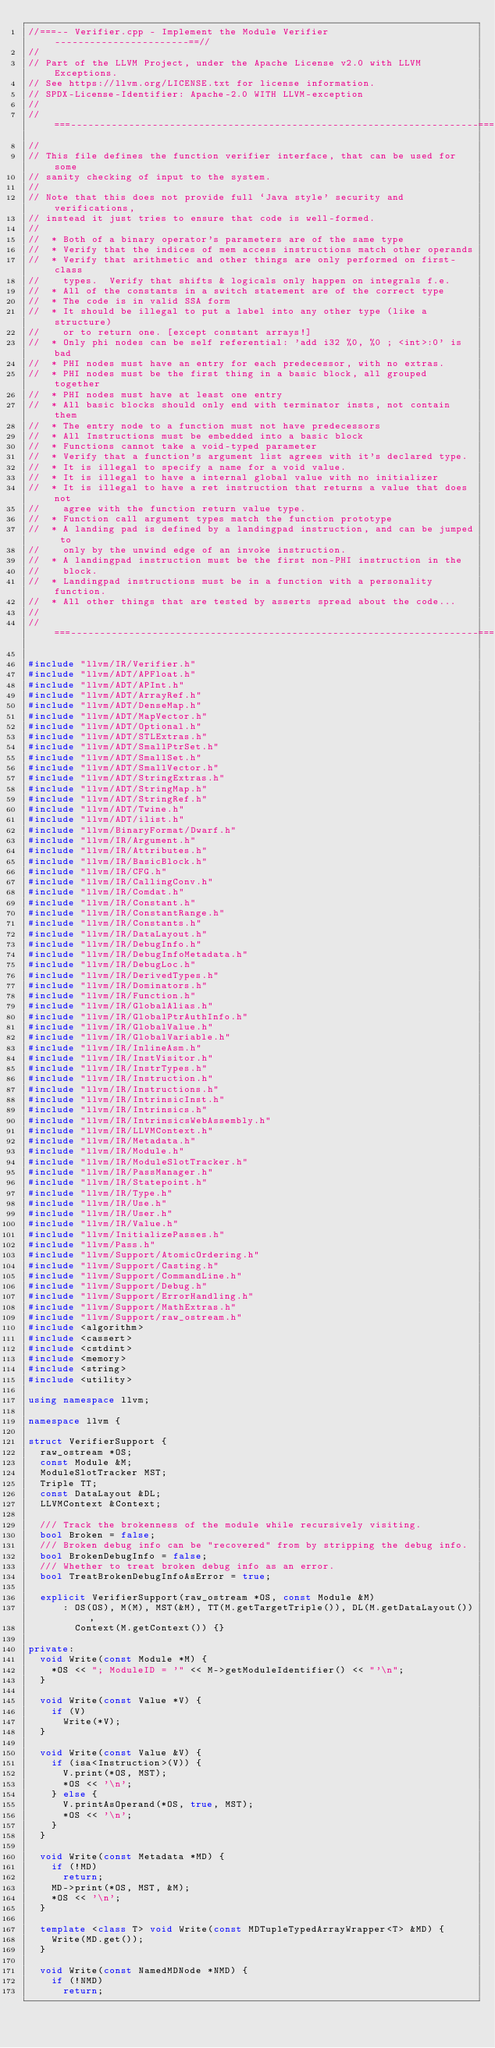Convert code to text. <code><loc_0><loc_0><loc_500><loc_500><_C++_>//===-- Verifier.cpp - Implement the Module Verifier -----------------------==//
//
// Part of the LLVM Project, under the Apache License v2.0 with LLVM Exceptions.
// See https://llvm.org/LICENSE.txt for license information.
// SPDX-License-Identifier: Apache-2.0 WITH LLVM-exception
//
//===----------------------------------------------------------------------===//
//
// This file defines the function verifier interface, that can be used for some
// sanity checking of input to the system.
//
// Note that this does not provide full `Java style' security and verifications,
// instead it just tries to ensure that code is well-formed.
//
//  * Both of a binary operator's parameters are of the same type
//  * Verify that the indices of mem access instructions match other operands
//  * Verify that arithmetic and other things are only performed on first-class
//    types.  Verify that shifts & logicals only happen on integrals f.e.
//  * All of the constants in a switch statement are of the correct type
//  * The code is in valid SSA form
//  * It should be illegal to put a label into any other type (like a structure)
//    or to return one. [except constant arrays!]
//  * Only phi nodes can be self referential: 'add i32 %0, %0 ; <int>:0' is bad
//  * PHI nodes must have an entry for each predecessor, with no extras.
//  * PHI nodes must be the first thing in a basic block, all grouped together
//  * PHI nodes must have at least one entry
//  * All basic blocks should only end with terminator insts, not contain them
//  * The entry node to a function must not have predecessors
//  * All Instructions must be embedded into a basic block
//  * Functions cannot take a void-typed parameter
//  * Verify that a function's argument list agrees with it's declared type.
//  * It is illegal to specify a name for a void value.
//  * It is illegal to have a internal global value with no initializer
//  * It is illegal to have a ret instruction that returns a value that does not
//    agree with the function return value type.
//  * Function call argument types match the function prototype
//  * A landing pad is defined by a landingpad instruction, and can be jumped to
//    only by the unwind edge of an invoke instruction.
//  * A landingpad instruction must be the first non-PHI instruction in the
//    block.
//  * Landingpad instructions must be in a function with a personality function.
//  * All other things that are tested by asserts spread about the code...
//
//===----------------------------------------------------------------------===//

#include "llvm/IR/Verifier.h"
#include "llvm/ADT/APFloat.h"
#include "llvm/ADT/APInt.h"
#include "llvm/ADT/ArrayRef.h"
#include "llvm/ADT/DenseMap.h"
#include "llvm/ADT/MapVector.h"
#include "llvm/ADT/Optional.h"
#include "llvm/ADT/STLExtras.h"
#include "llvm/ADT/SmallPtrSet.h"
#include "llvm/ADT/SmallSet.h"
#include "llvm/ADT/SmallVector.h"
#include "llvm/ADT/StringExtras.h"
#include "llvm/ADT/StringMap.h"
#include "llvm/ADT/StringRef.h"
#include "llvm/ADT/Twine.h"
#include "llvm/ADT/ilist.h"
#include "llvm/BinaryFormat/Dwarf.h"
#include "llvm/IR/Argument.h"
#include "llvm/IR/Attributes.h"
#include "llvm/IR/BasicBlock.h"
#include "llvm/IR/CFG.h"
#include "llvm/IR/CallingConv.h"
#include "llvm/IR/Comdat.h"
#include "llvm/IR/Constant.h"
#include "llvm/IR/ConstantRange.h"
#include "llvm/IR/Constants.h"
#include "llvm/IR/DataLayout.h"
#include "llvm/IR/DebugInfo.h"
#include "llvm/IR/DebugInfoMetadata.h"
#include "llvm/IR/DebugLoc.h"
#include "llvm/IR/DerivedTypes.h"
#include "llvm/IR/Dominators.h"
#include "llvm/IR/Function.h"
#include "llvm/IR/GlobalAlias.h"
#include "llvm/IR/GlobalPtrAuthInfo.h"
#include "llvm/IR/GlobalValue.h"
#include "llvm/IR/GlobalVariable.h"
#include "llvm/IR/InlineAsm.h"
#include "llvm/IR/InstVisitor.h"
#include "llvm/IR/InstrTypes.h"
#include "llvm/IR/Instruction.h"
#include "llvm/IR/Instructions.h"
#include "llvm/IR/IntrinsicInst.h"
#include "llvm/IR/Intrinsics.h"
#include "llvm/IR/IntrinsicsWebAssembly.h"
#include "llvm/IR/LLVMContext.h"
#include "llvm/IR/Metadata.h"
#include "llvm/IR/Module.h"
#include "llvm/IR/ModuleSlotTracker.h"
#include "llvm/IR/PassManager.h"
#include "llvm/IR/Statepoint.h"
#include "llvm/IR/Type.h"
#include "llvm/IR/Use.h"
#include "llvm/IR/User.h"
#include "llvm/IR/Value.h"
#include "llvm/InitializePasses.h"
#include "llvm/Pass.h"
#include "llvm/Support/AtomicOrdering.h"
#include "llvm/Support/Casting.h"
#include "llvm/Support/CommandLine.h"
#include "llvm/Support/Debug.h"
#include "llvm/Support/ErrorHandling.h"
#include "llvm/Support/MathExtras.h"
#include "llvm/Support/raw_ostream.h"
#include <algorithm>
#include <cassert>
#include <cstdint>
#include <memory>
#include <string>
#include <utility>

using namespace llvm;

namespace llvm {

struct VerifierSupport {
  raw_ostream *OS;
  const Module &M;
  ModuleSlotTracker MST;
  Triple TT;
  const DataLayout &DL;
  LLVMContext &Context;

  /// Track the brokenness of the module while recursively visiting.
  bool Broken = false;
  /// Broken debug info can be "recovered" from by stripping the debug info.
  bool BrokenDebugInfo = false;
  /// Whether to treat broken debug info as an error.
  bool TreatBrokenDebugInfoAsError = true;

  explicit VerifierSupport(raw_ostream *OS, const Module &M)
      : OS(OS), M(M), MST(&M), TT(M.getTargetTriple()), DL(M.getDataLayout()),
        Context(M.getContext()) {}

private:
  void Write(const Module *M) {
    *OS << "; ModuleID = '" << M->getModuleIdentifier() << "'\n";
  }

  void Write(const Value *V) {
    if (V)
      Write(*V);
  }

  void Write(const Value &V) {
    if (isa<Instruction>(V)) {
      V.print(*OS, MST);
      *OS << '\n';
    } else {
      V.printAsOperand(*OS, true, MST);
      *OS << '\n';
    }
  }

  void Write(const Metadata *MD) {
    if (!MD)
      return;
    MD->print(*OS, MST, &M);
    *OS << '\n';
  }

  template <class T> void Write(const MDTupleTypedArrayWrapper<T> &MD) {
    Write(MD.get());
  }

  void Write(const NamedMDNode *NMD) {
    if (!NMD)
      return;</code> 